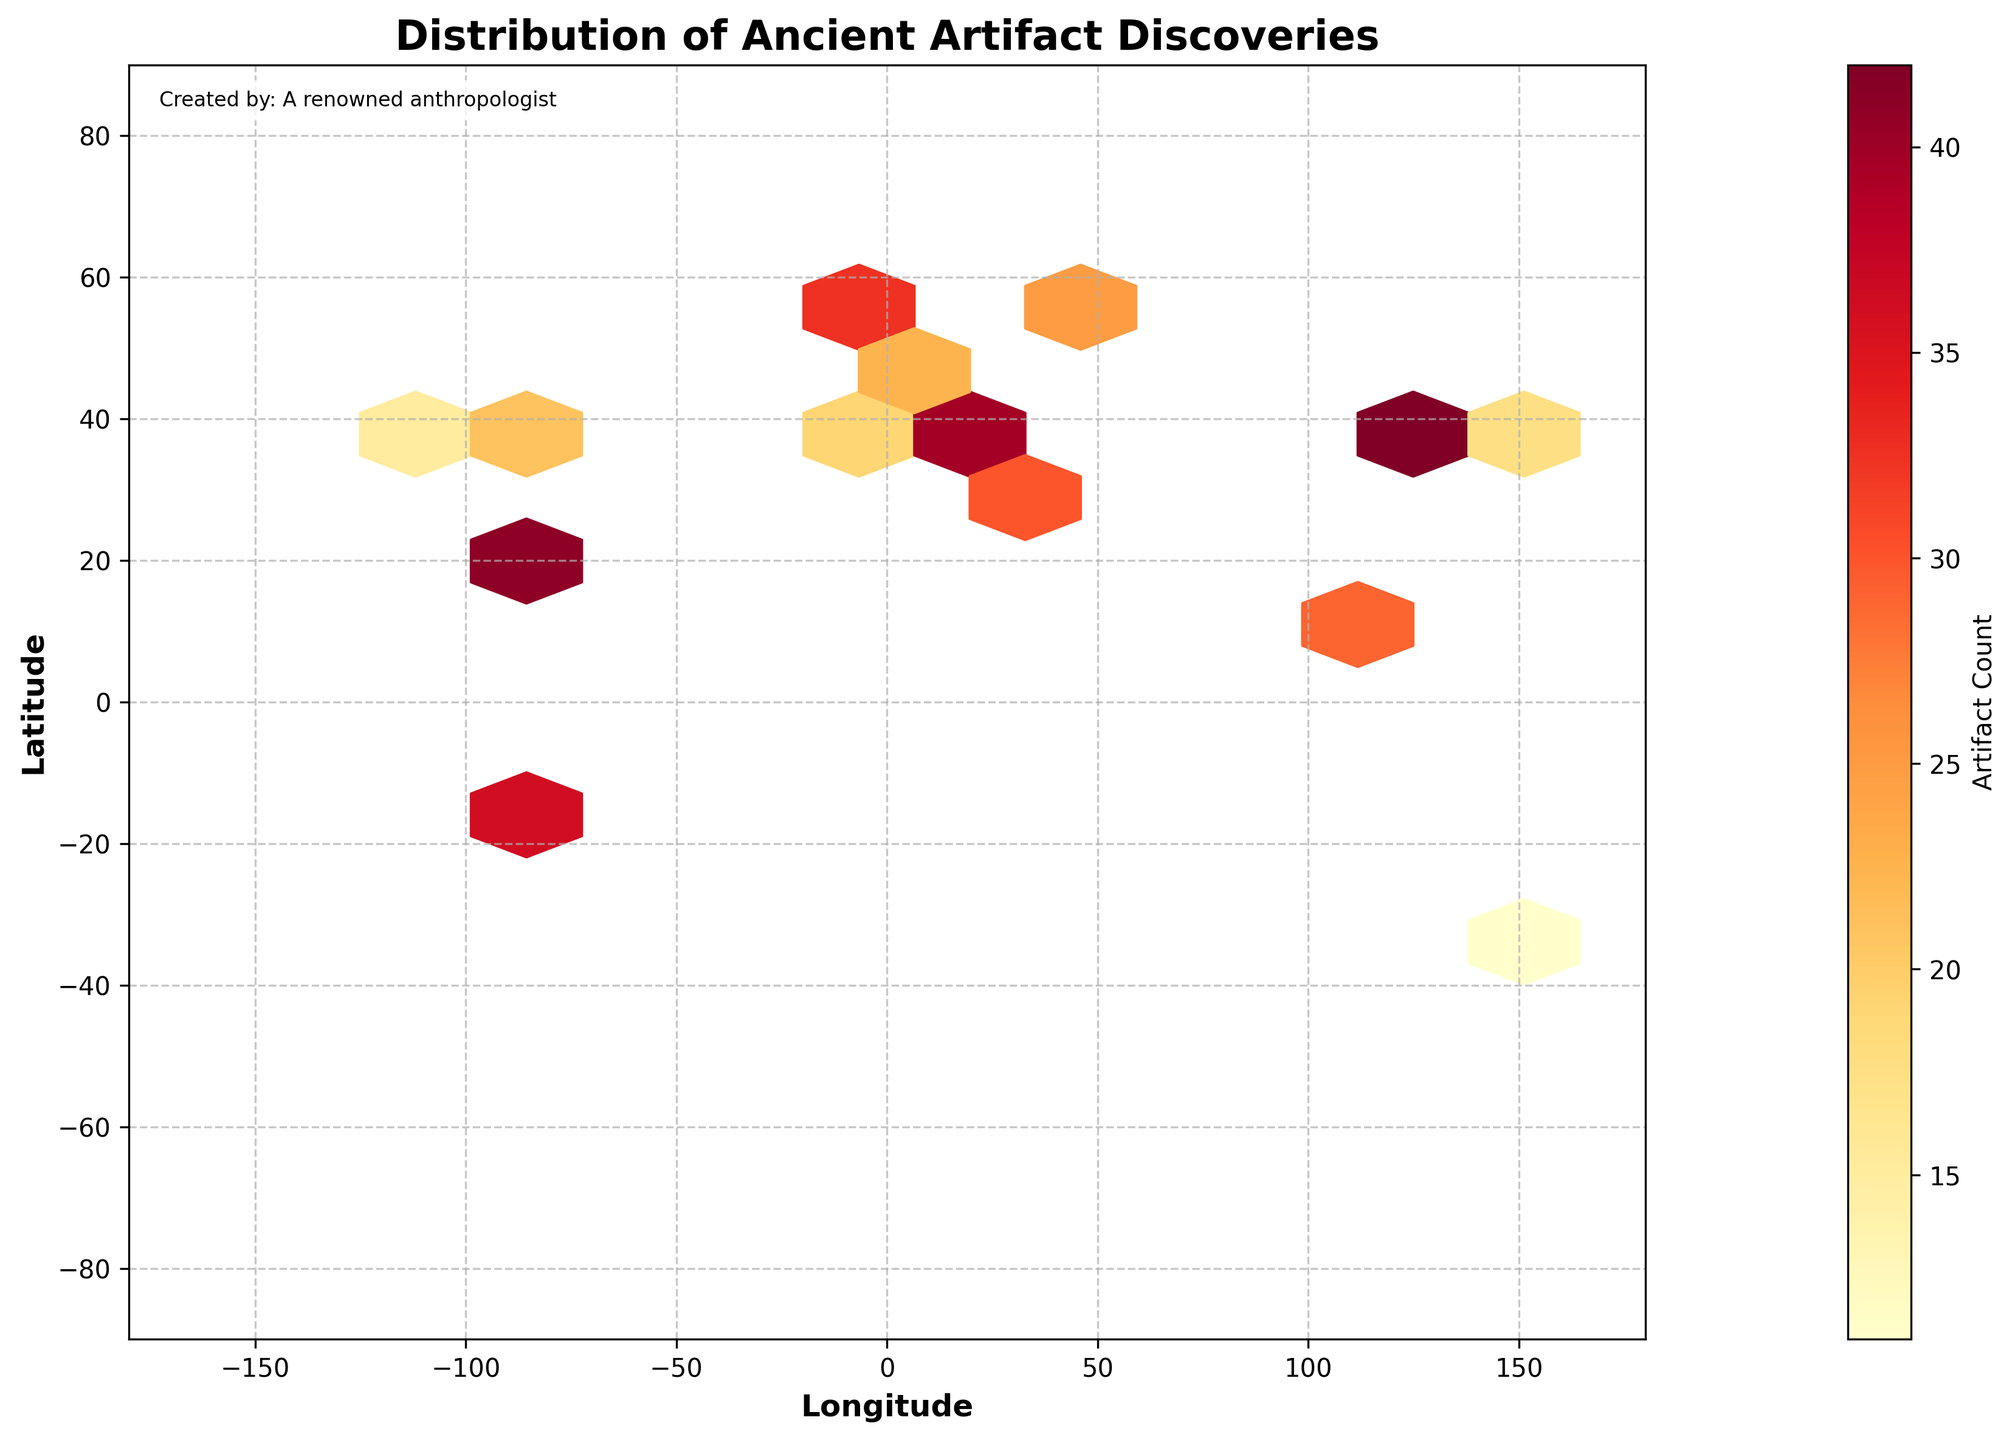How many hexagons are shown in the hexbin plot? We need to count the distinct hexagons visible in the entire plot area.
Answer: 10 What color represents the highest concentration of artifacts? We need to look at the color gradient and find the color that represents the maximum value in the colorbar legend.
Answer: Deep red What is the title of the hexbin plot? We can find the title at the top of the plot area.
Answer: Distribution of Ancient Artifact Discoveries Which geographic coordinates have the lowest artifact count? Observe the color shade of hexagons and find the one closest to the lightest color in the color spectrum provided.
Answer: 33.812511, -111.911390 How does the artifact count vary with different geographic regions? By examining the distribution of various colors in different regions across the hexbin plot, we can observe and compare the artifact count variations.
Answer: It varies significantly across regions with higher counts near locations like Europe and Asia What does the x-axis represent in the hexbin plot? Check the label beneath the horizontal axis.
Answer: Longitude What does the y-axis represent in the hexbin plot? Check the label beside the vertical axis.
Answer: Latitude Between the latitude values of 10 and 40, what artifact count colors are most commonly observed? Observe the shades of colors within this latitude range across the plot and compare them against the colorbar legend to determine the common artifact count colors.
Answer: Light to medium orange Are there more artifact discoveries in the Northern hemisphere compared to the Southern hemisphere in the plot? Count and compare the number of hexagons or color intensity distribution in the upper half (Northern hemisphere) versus the lower half (Southern hemisphere) of the plot.
Answer: Yes, the Northern hemisphere shows a higher concentration of artifact discoveries Which longitude range has the highest concentration of artifacts? Identify longitude regions where the hexagon colors indicate the highest artifact counts.
Answer: Longitude: 0 to 40 